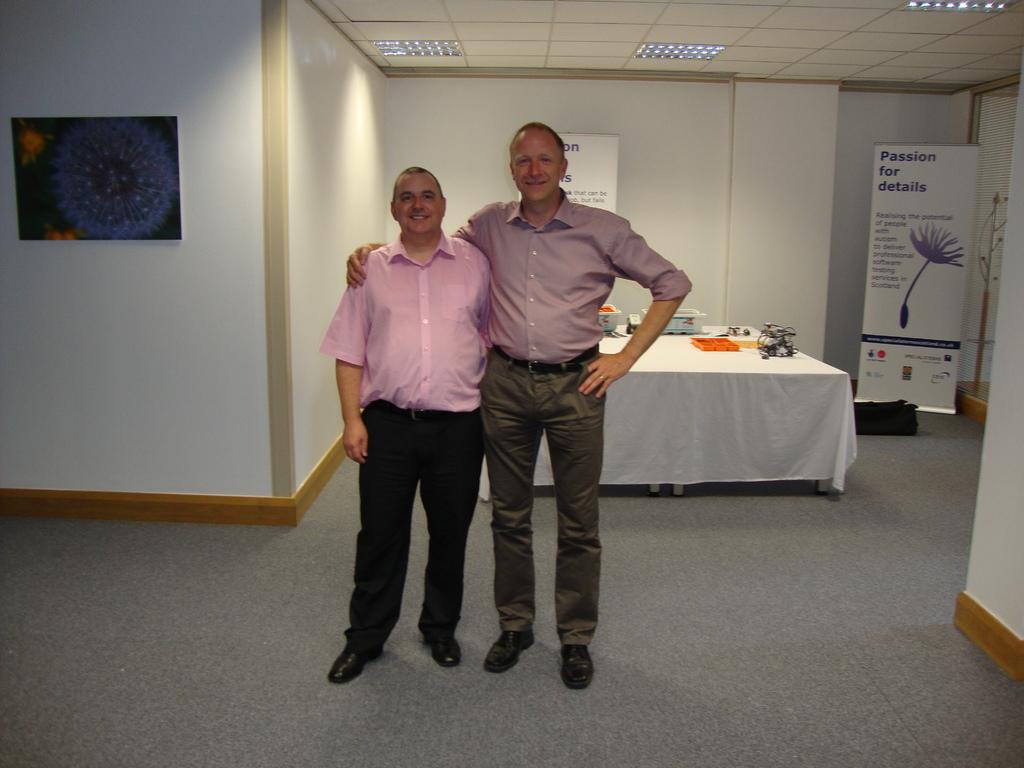Can you describe this image briefly? In this picture we can see two people on the floor and they are smiling and in the background we can see a wall, boards, table, roof, lights and some objects. 